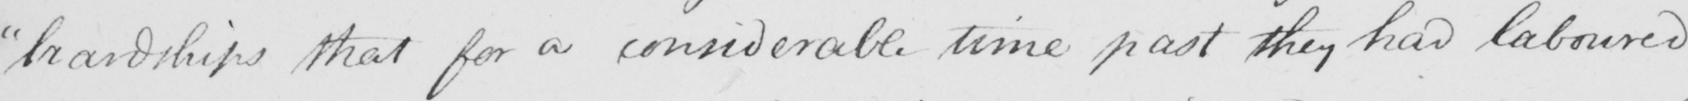What does this handwritten line say? " hardships that for a considerable time past they had laboured 